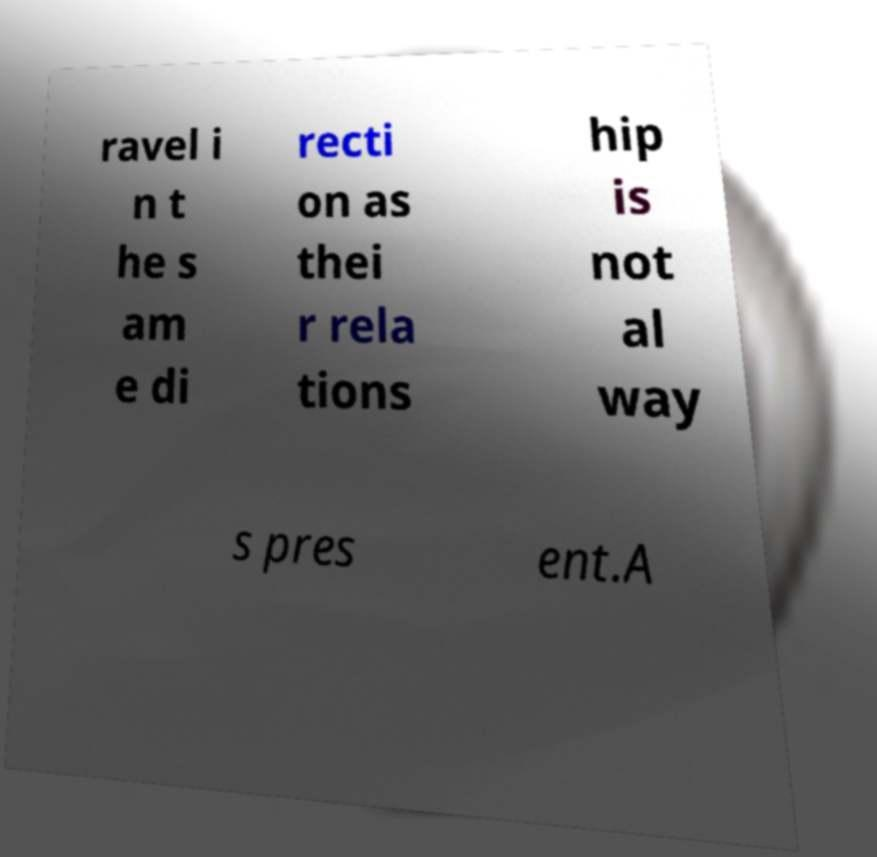What messages or text are displayed in this image? I need them in a readable, typed format. ravel i n t he s am e di recti on as thei r rela tions hip is not al way s pres ent.A 